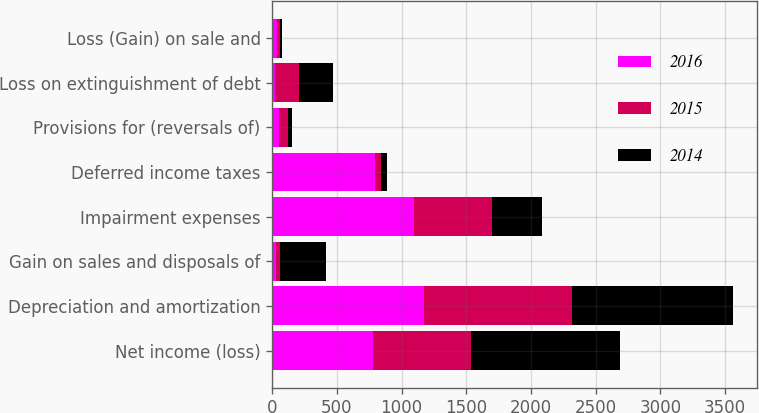<chart> <loc_0><loc_0><loc_500><loc_500><stacked_bar_chart><ecel><fcel>Net income (loss)<fcel>Depreciation and amortization<fcel>Gain on sales and disposals of<fcel>Impairment expenses<fcel>Deferred income taxes<fcel>Provisions for (reversals of)<fcel>Loss on extinguishment of debt<fcel>Loss (Gain) on sale and<nl><fcel>2016<fcel>777<fcel>1176<fcel>29<fcel>1098<fcel>793<fcel>48<fcel>20<fcel>38<nl><fcel>2015<fcel>762<fcel>1144<fcel>29<fcel>602<fcel>50<fcel>72<fcel>186<fcel>20<nl><fcel>2014<fcel>1147<fcel>1245<fcel>358<fcel>383<fcel>47<fcel>34<fcel>261<fcel>20<nl></chart> 